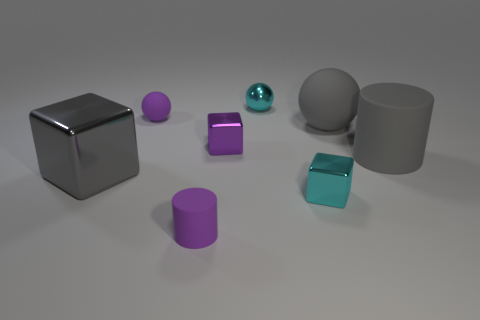What materials do the objects in the image appear to be made of, based on their reflections and textures? The objects in the image give the impression of being composed of various materials. The large gray objects, both the cube and the cylinder, appear metallic due to their shiny, reflective surfaces. The smaller cylinders, one purple and one greenish-blue, seem to have a matte finish which may suggest a plastic or painted metal material. The small metallic sphere looks like it could be either polished steel or chrome due to its mirror-like reflection. 